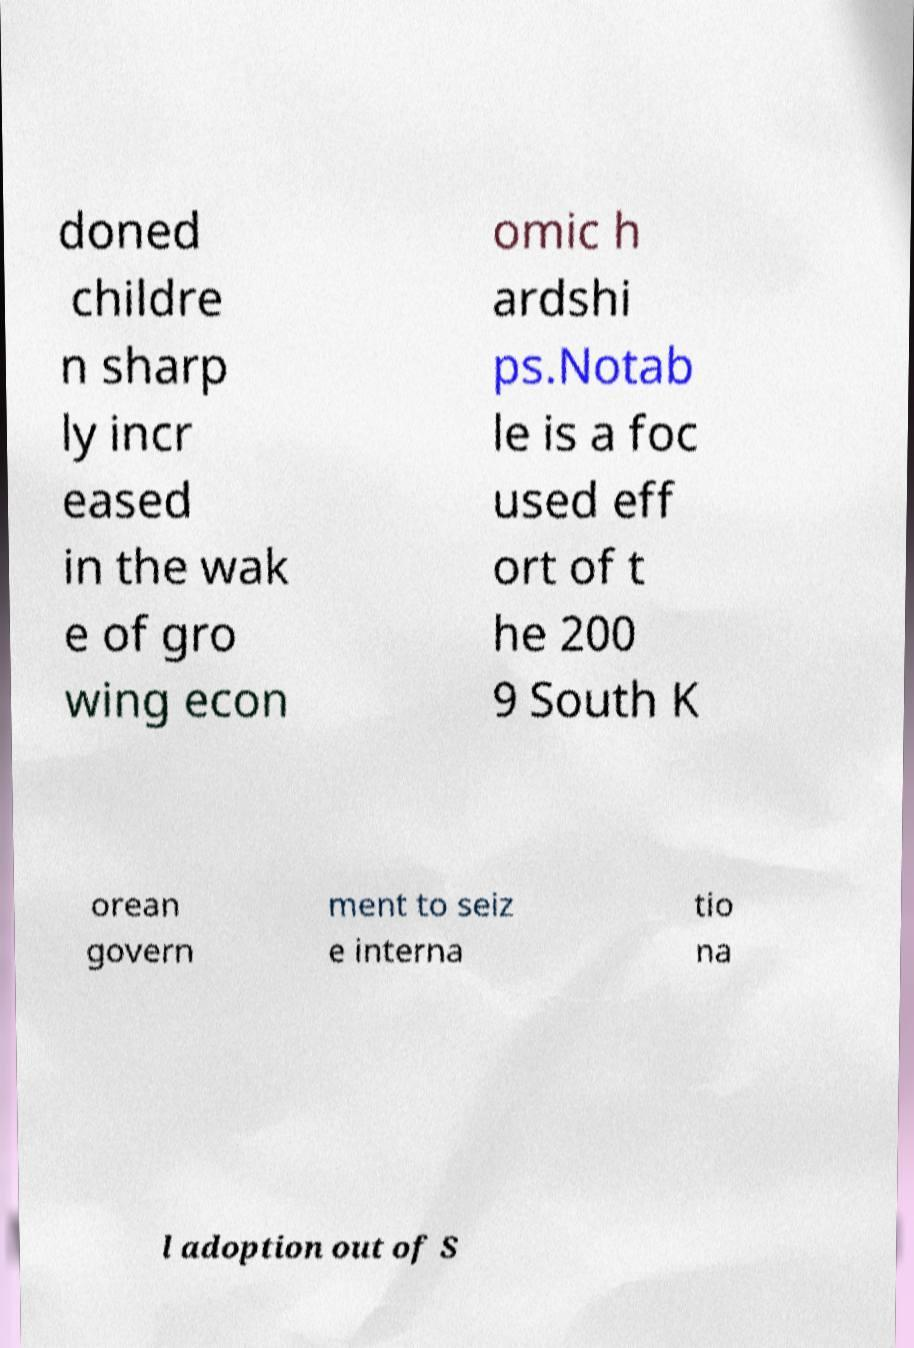Could you assist in decoding the text presented in this image and type it out clearly? doned childre n sharp ly incr eased in the wak e of gro wing econ omic h ardshi ps.Notab le is a foc used eff ort of t he 200 9 South K orean govern ment to seiz e interna tio na l adoption out of S 